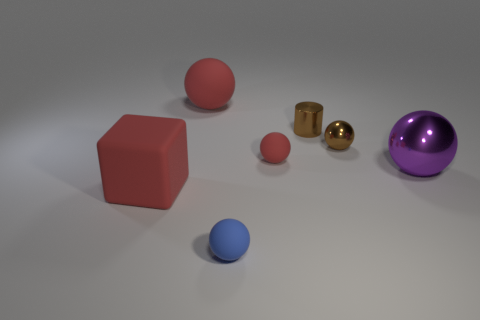Which objects in the image appear to have reflective surfaces? The objects with reflective surfaces in the image are the two small cylinders (one gold and one silver) and the large purple sphere. 